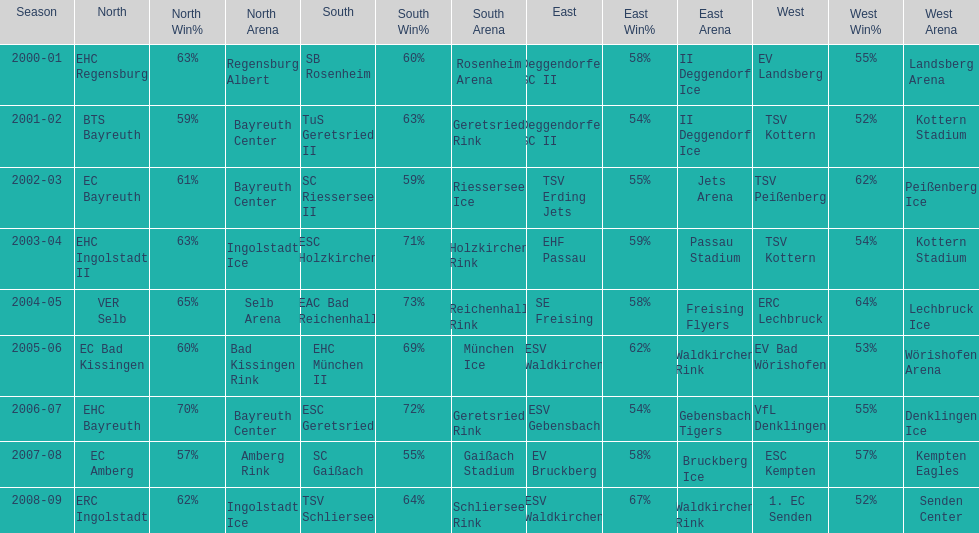The only team to win the north in 2000-01 season? EHC Regensburg. Would you be able to parse every entry in this table? {'header': ['Season', 'North', 'North Win%', 'North Arena', 'South', 'South Win%', 'South Arena', 'East', 'East Win%', 'East Arena', 'West', 'West Win%', 'West Arena'], 'rows': [['2000-01', 'EHC Regensburg', '63%', 'Regensburg Albert', 'SB Rosenheim', '60%', 'Rosenheim Arena', 'Deggendorfer SC II', '58%', 'II Deggendorf Ice', 'EV Landsberg', '55%', 'Landsberg Arena'], ['2001-02', 'BTS Bayreuth', '59%', 'Bayreuth Center', 'TuS Geretsried II', '63%', 'Geretsried Rink', 'Deggendorfer SC II', '54%', 'II Deggendorf Ice', 'TSV Kottern', '52%', 'Kottern Stadium'], ['2002-03', 'EC Bayreuth', '61%', 'Bayreuth Center', 'SC Riessersee II', '59%', 'Riessersee Ice', 'TSV Erding Jets', '55%', 'Jets Arena', 'TSV Peißenberg', '62%', 'Peißenberg Ice'], ['2003-04', 'EHC Ingolstadt II', '63%', 'Ingolstadt Ice', 'ESC Holzkirchen', '71%', 'Holzkirchen Rink', 'EHF Passau', '59%', 'Passau Stadium', 'TSV Kottern', '54%', 'Kottern Stadium'], ['2004-05', 'VER Selb', '65%', 'Selb Arena', 'EAC Bad Reichenhall', '73%', 'Reichenhall Rink', 'SE Freising', '58%', 'Freising Flyers', 'ERC Lechbruck', '64%', 'Lechbruck Ice'], ['2005-06', 'EC Bad Kissingen', '60%', 'Bad Kissingen Rink', 'EHC München II', '69%', 'München Ice', 'ESV Waldkirchen', '62%', 'Waldkirchen Rink', 'EV Bad Wörishofen', '53%', 'Wörishofen Arena'], ['2006-07', 'EHC Bayreuth', '70%', 'Bayreuth Center', 'ESC Geretsried', '72%', 'Geretsried Rink', 'ESV Gebensbach', '54%', 'Gebensbach Tigers', 'VfL Denklingen', '55%', 'Denklingen Ice'], ['2007-08', 'EC Amberg', '57%', 'Amberg Rink', 'SC Gaißach', '55%', 'Gaißach Stadium', 'EV Bruckberg', '58%', 'Bruckberg Ice', 'ESC Kempten', '57%', 'Kempten Eagles'], ['2008-09', 'ERC Ingolstadt', '62%', 'Ingolstadt Ice', 'TSV Schliersee', '64%', 'Schliersee Rink', 'ESV Waldkirchen', '67%', 'Waldkirchen Rink', '1. EC Senden', '52%', 'Senden Center']]} 